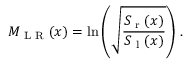Convert formula to latex. <formula><loc_0><loc_0><loc_500><loc_500>M _ { L R } ( x ) = \ln { \left ( \sqrt { \frac { S _ { r } ( x ) } { S _ { l } ( x ) } } \right ) } \ .</formula> 